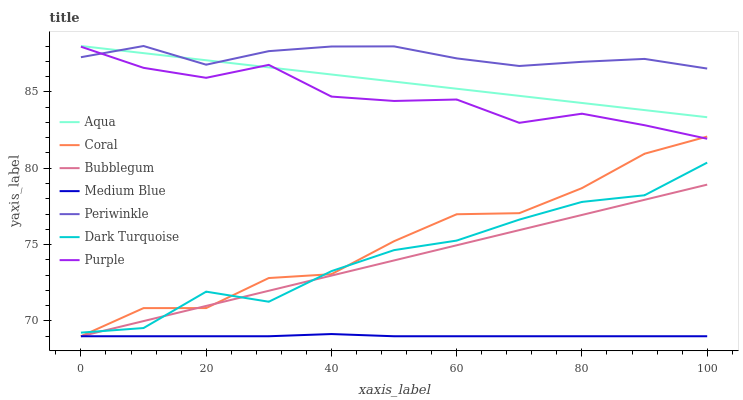Does Aqua have the minimum area under the curve?
Answer yes or no. No. Does Aqua have the maximum area under the curve?
Answer yes or no. No. Is Aqua the smoothest?
Answer yes or no. No. Is Aqua the roughest?
Answer yes or no. No. Does Aqua have the lowest value?
Answer yes or no. No. Does Coral have the highest value?
Answer yes or no. No. Is Medium Blue less than Periwinkle?
Answer yes or no. Yes. Is Purple greater than Bubblegum?
Answer yes or no. Yes. Does Medium Blue intersect Periwinkle?
Answer yes or no. No. 